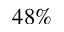<formula> <loc_0><loc_0><loc_500><loc_500>4 8 \%</formula> 